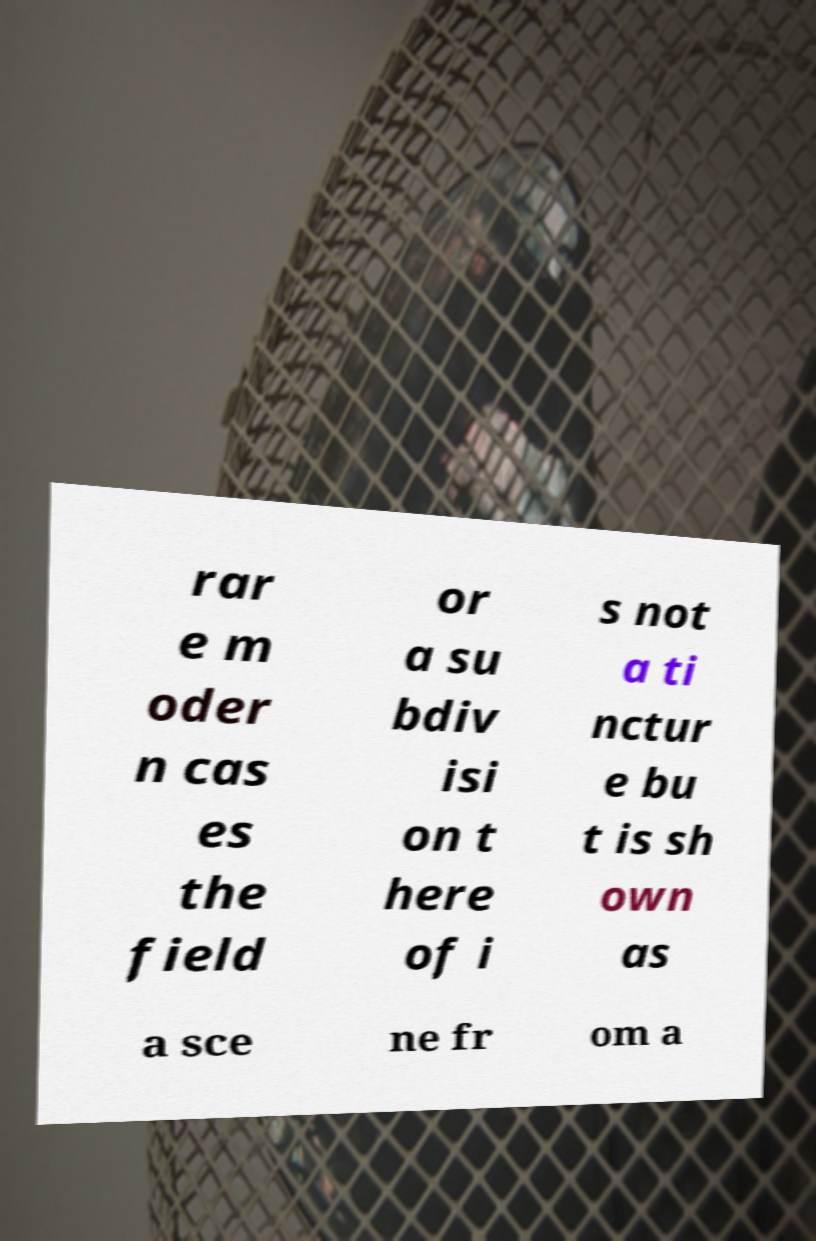What messages or text are displayed in this image? I need them in a readable, typed format. rar e m oder n cas es the field or a su bdiv isi on t here of i s not a ti nctur e bu t is sh own as a sce ne fr om a 